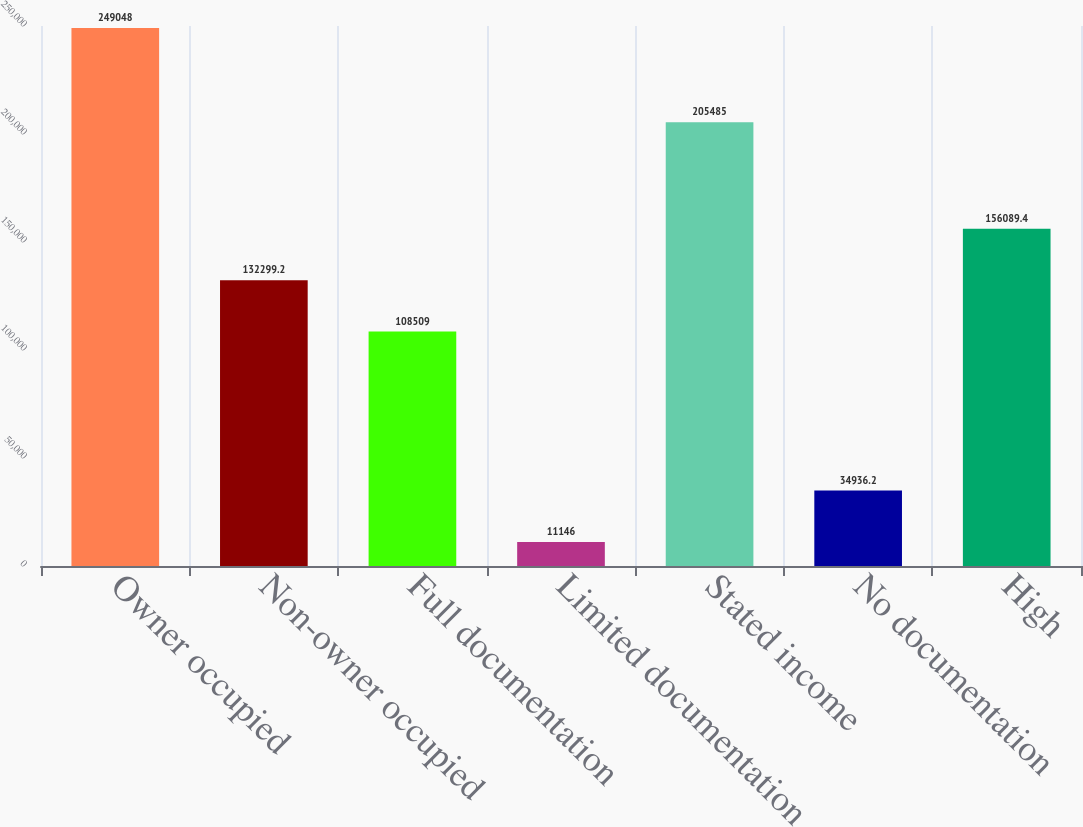Convert chart. <chart><loc_0><loc_0><loc_500><loc_500><bar_chart><fcel>Owner occupied<fcel>Non-owner occupied<fcel>Full documentation<fcel>Limited documentation<fcel>Stated income<fcel>No documentation<fcel>High<nl><fcel>249048<fcel>132299<fcel>108509<fcel>11146<fcel>205485<fcel>34936.2<fcel>156089<nl></chart> 